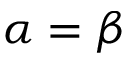Convert formula to latex. <formula><loc_0><loc_0><loc_500><loc_500>\alpha = \beta</formula> 